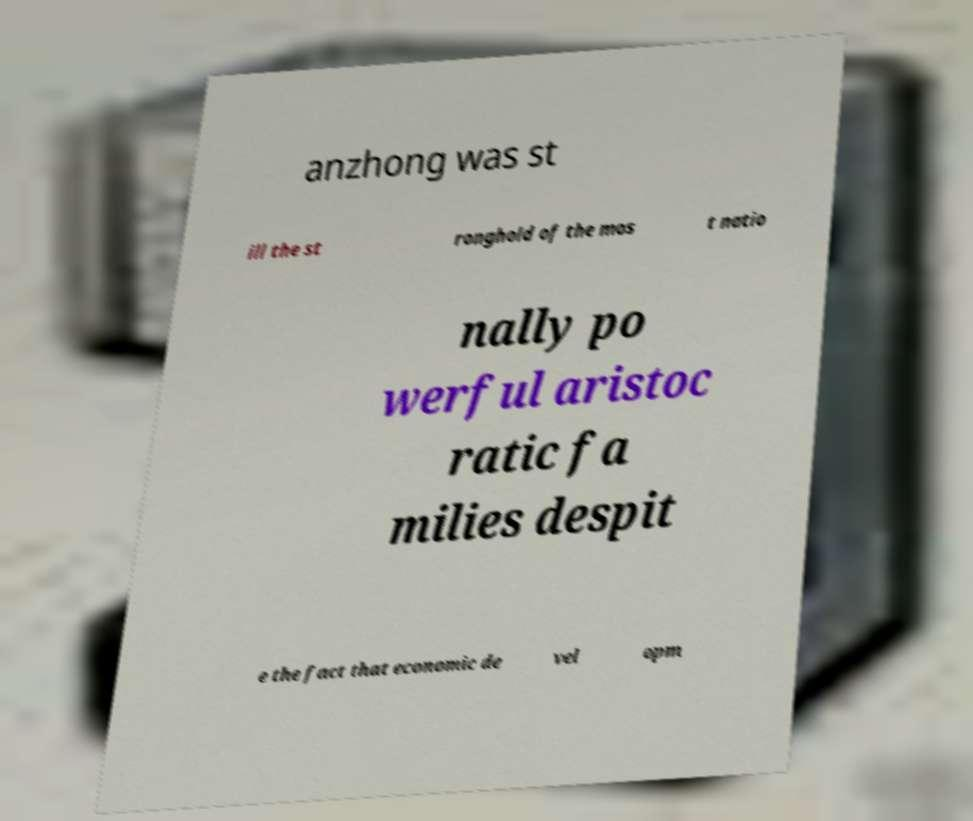Please read and relay the text visible in this image. What does it say? anzhong was st ill the st ronghold of the mos t natio nally po werful aristoc ratic fa milies despit e the fact that economic de vel opm 